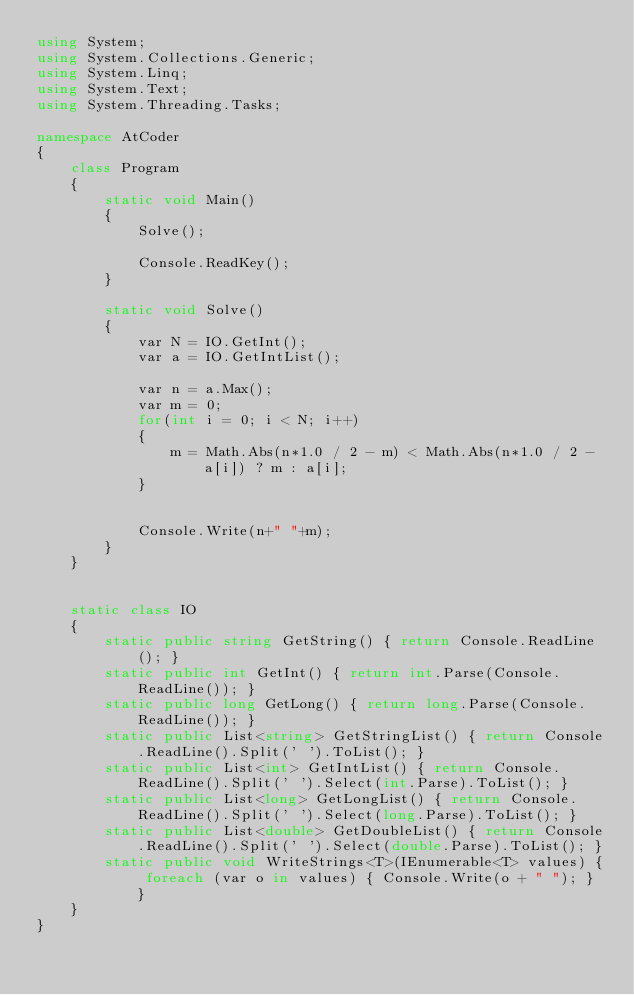Convert code to text. <code><loc_0><loc_0><loc_500><loc_500><_C#_>using System;
using System.Collections.Generic;
using System.Linq;
using System.Text;
using System.Threading.Tasks;

namespace AtCoder
{
    class Program
    {
        static void Main()
        {
            Solve();

            Console.ReadKey();
        }

        static void Solve()
        {
            var N = IO.GetInt();
            var a = IO.GetIntList();

            var n = a.Max();
            var m = 0;
            for(int i = 0; i < N; i++)
            {
                m = Math.Abs(n*1.0 / 2 - m) < Math.Abs(n*1.0 / 2 - a[i]) ? m : a[i];
            }


            Console.Write(n+" "+m);
        }
    }


    static class IO
    {
        static public string GetString() { return Console.ReadLine(); }
        static public int GetInt() { return int.Parse(Console.ReadLine()); }
        static public long GetLong() { return long.Parse(Console.ReadLine()); }
        static public List<string> GetStringList() { return Console.ReadLine().Split(' ').ToList(); }
        static public List<int> GetIntList() { return Console.ReadLine().Split(' ').Select(int.Parse).ToList(); }
        static public List<long> GetLongList() { return Console.ReadLine().Split(' ').Select(long.Parse).ToList(); }
        static public List<double> GetDoubleList() { return Console.ReadLine().Split(' ').Select(double.Parse).ToList(); }
        static public void WriteStrings<T>(IEnumerable<T> values) { foreach (var o in values) { Console.Write(o + " "); } }
    }
}</code> 